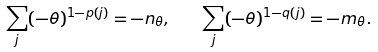Convert formula to latex. <formula><loc_0><loc_0><loc_500><loc_500>\sum _ { j } ( - \theta ) ^ { 1 - p ( j ) } = - n _ { \theta } , \quad \sum _ { j } ( - \theta ) ^ { 1 - q ( j ) } = - m _ { \theta } .</formula> 